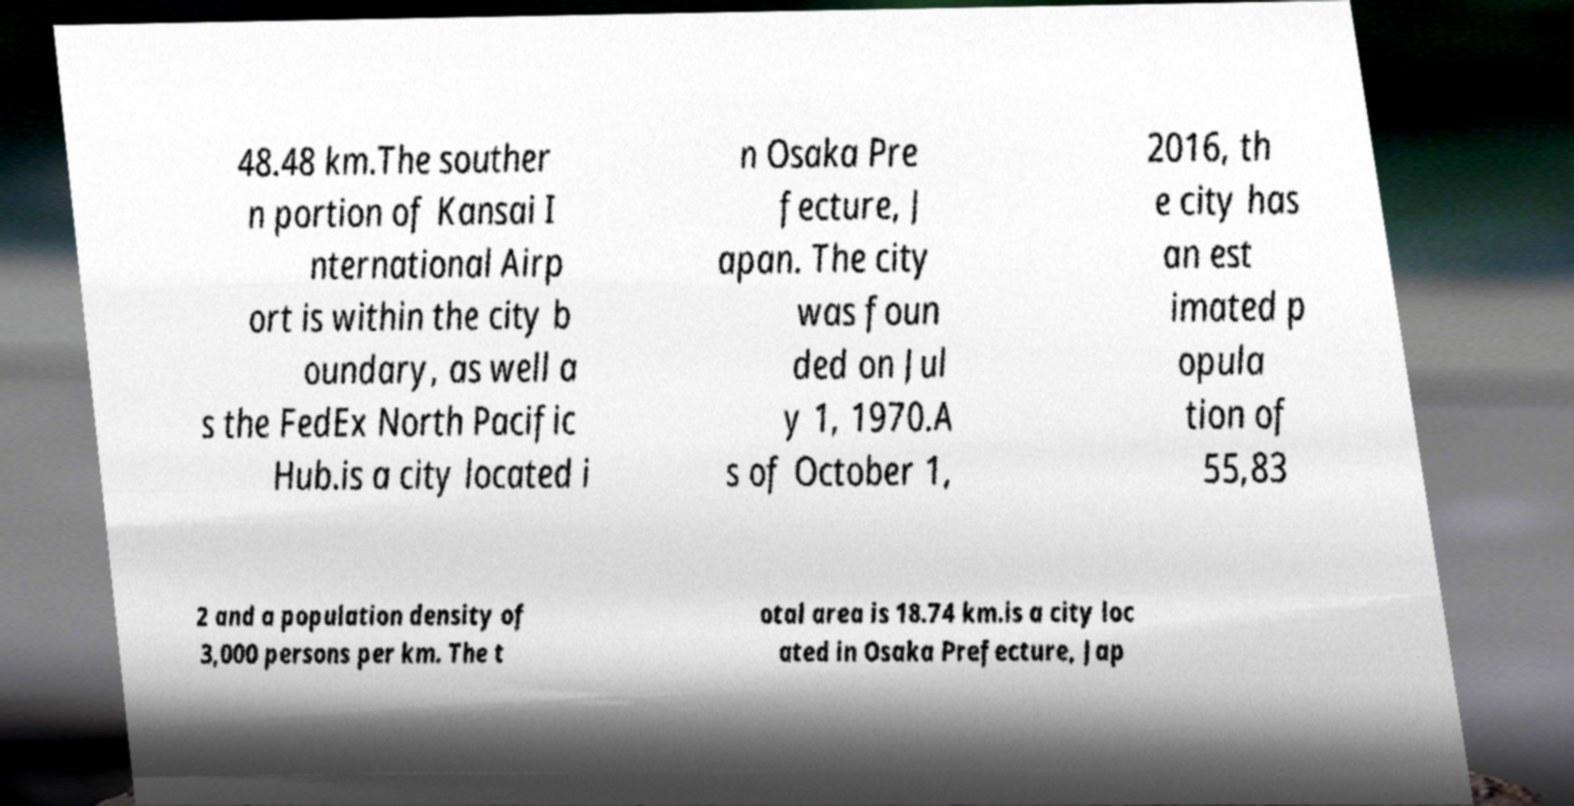There's text embedded in this image that I need extracted. Can you transcribe it verbatim? 48.48 km.The souther n portion of Kansai I nternational Airp ort is within the city b oundary, as well a s the FedEx North Pacific Hub.is a city located i n Osaka Pre fecture, J apan. The city was foun ded on Jul y 1, 1970.A s of October 1, 2016, th e city has an est imated p opula tion of 55,83 2 and a population density of 3,000 persons per km. The t otal area is 18.74 km.is a city loc ated in Osaka Prefecture, Jap 